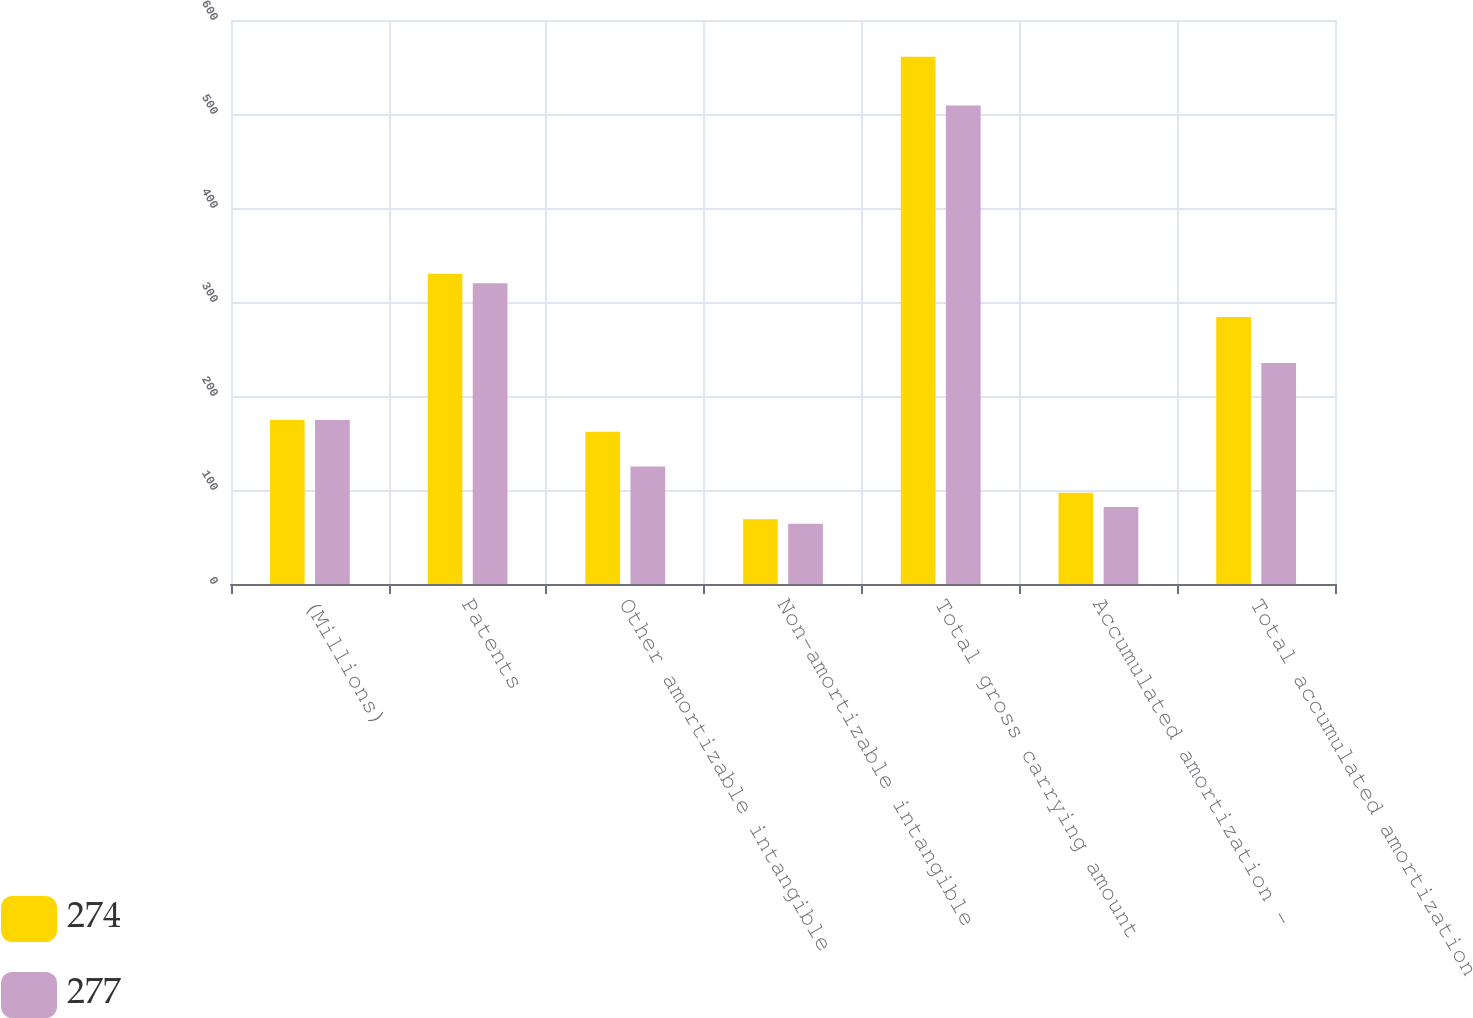Convert chart. <chart><loc_0><loc_0><loc_500><loc_500><stacked_bar_chart><ecel><fcel>(Millions)<fcel>Patents<fcel>Other amortizable intangible<fcel>Non-amortizable intangible<fcel>Total gross carrying amount<fcel>Accumulated amortization -<fcel>Total accumulated amortization<nl><fcel>274<fcel>174.5<fcel>330<fcel>162<fcel>69<fcel>561<fcel>97<fcel>284<nl><fcel>277<fcel>174.5<fcel>320<fcel>125<fcel>64<fcel>509<fcel>82<fcel>235<nl></chart> 